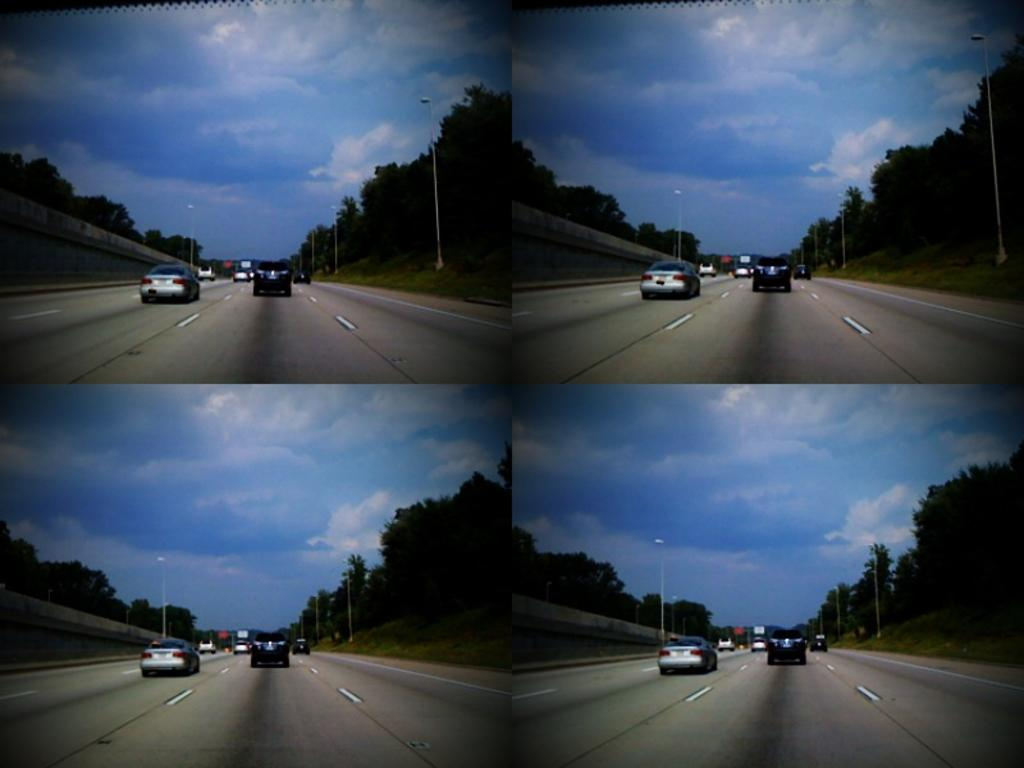What is the composition of the image? The image is a collage of similar pictures. What is happening on the road in the image? Cars are moving on the road in the image. What type of vegetation can be seen in the image? There are trees visible in the image. What type of lighting is present in the image? Pole lights are present in the image. How would you describe the sky in the image? The sky is blue and cloudy in the image. What type of string is being used to hold up the chin of the kitty in the image? There is no kitty or string present in the image. 